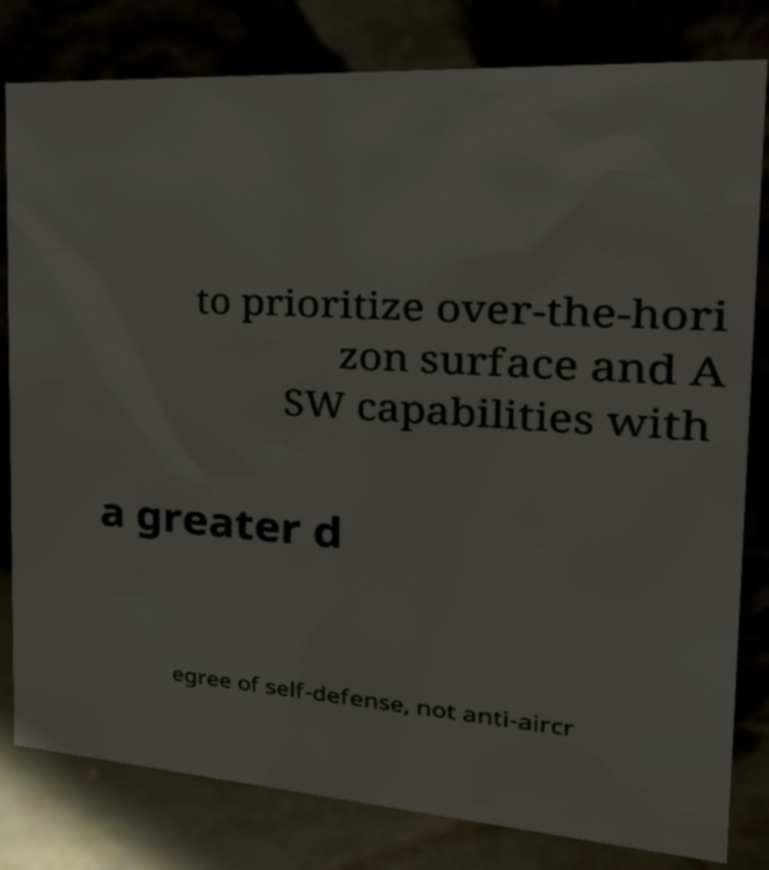Could you extract and type out the text from this image? to prioritize over-the-hori zon surface and A SW capabilities with a greater d egree of self-defense, not anti-aircr 